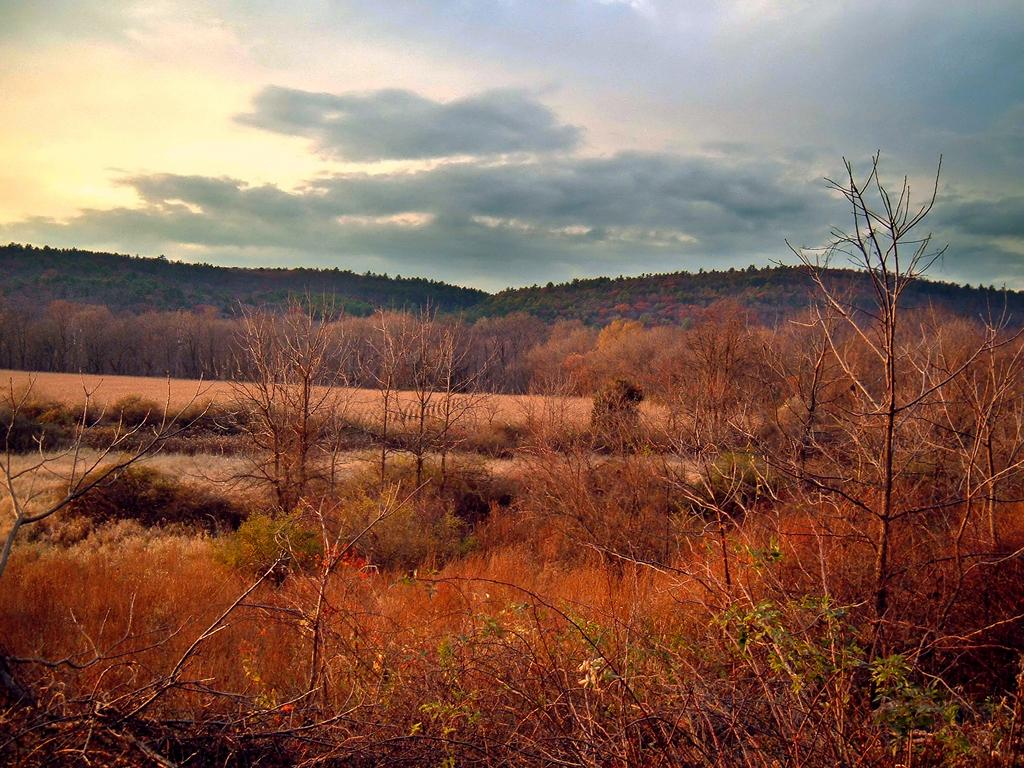What type of vegetation can be seen in the image? There are trees and plants in the image. What is located in the middle of the image? There is a hill in the middle of the image. What can be seen in the sky in the image? There are clouds in the sky. What type of wax can be seen melting on the hill in the image? There is no wax present in the image; it features trees, plants, a hill, and clouds. What is the best way to reach the top of the hill in the image? The image does not provide enough information to determine the best way to reach the top of the hill. 